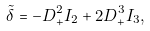Convert formula to latex. <formula><loc_0><loc_0><loc_500><loc_500>\tilde { \delta } = - D _ { + } ^ { 2 } I _ { 2 } + 2 D _ { + } ^ { 3 } I _ { 3 } ,</formula> 